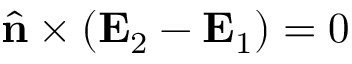<formula> <loc_0><loc_0><loc_500><loc_500>\hat { n } \times ( E _ { 2 } - E _ { 1 } ) = 0</formula> 